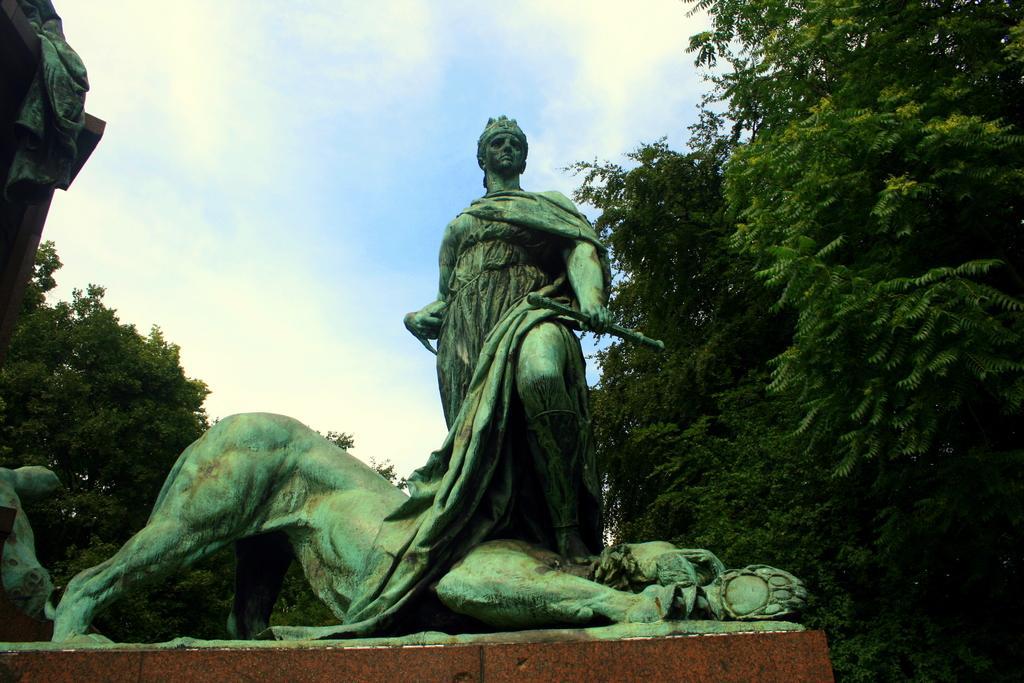Describe this image in one or two sentences. In this image I can see the statues, few trees and the sky is in blue and white color. 